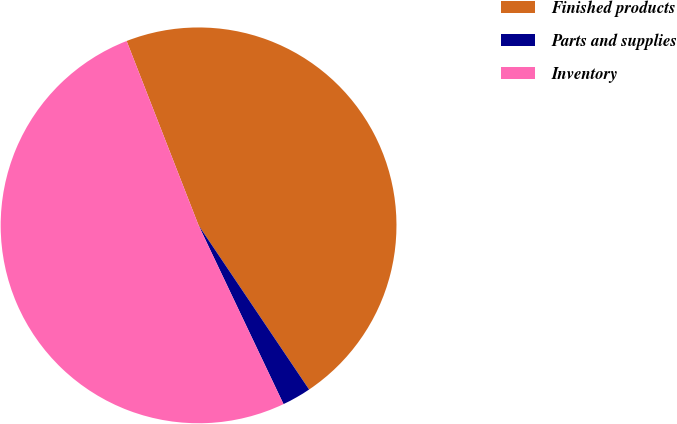Convert chart. <chart><loc_0><loc_0><loc_500><loc_500><pie_chart><fcel>Finished products<fcel>Parts and supplies<fcel>Inventory<nl><fcel>46.49%<fcel>2.37%<fcel>51.14%<nl></chart> 